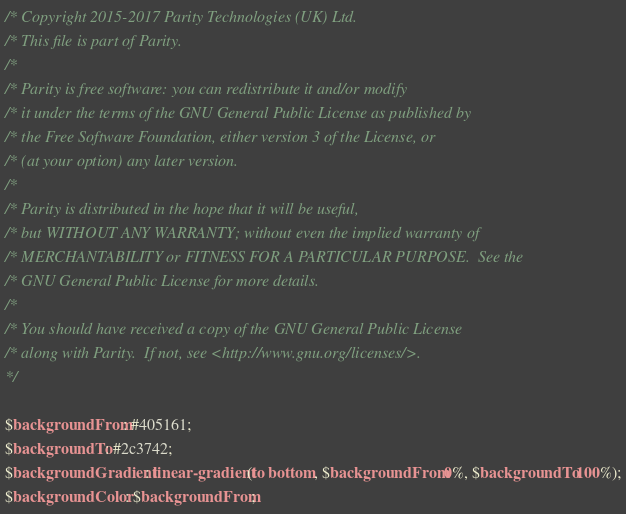<code> <loc_0><loc_0><loc_500><loc_500><_CSS_>/* Copyright 2015-2017 Parity Technologies (UK) Ltd.
/* This file is part of Parity.
/*
/* Parity is free software: you can redistribute it and/or modify
/* it under the terms of the GNU General Public License as published by
/* the Free Software Foundation, either version 3 of the License, or
/* (at your option) any later version.
/*
/* Parity is distributed in the hope that it will be useful,
/* but WITHOUT ANY WARRANTY; without even the implied warranty of
/* MERCHANTABILITY or FITNESS FOR A PARTICULAR PURPOSE.  See the
/* GNU General Public License for more details.
/*
/* You should have received a copy of the GNU General Public License
/* along with Parity.  If not, see <http://www.gnu.org/licenses/>.
*/

$backgroundFrom: #405161;
$backgroundTo: #2c3742;
$backgroundGradient: linear-gradient(to bottom, $backgroundFrom 0%, $backgroundTo 100%);
$backgroundColor: $backgroundFrom;
</code> 